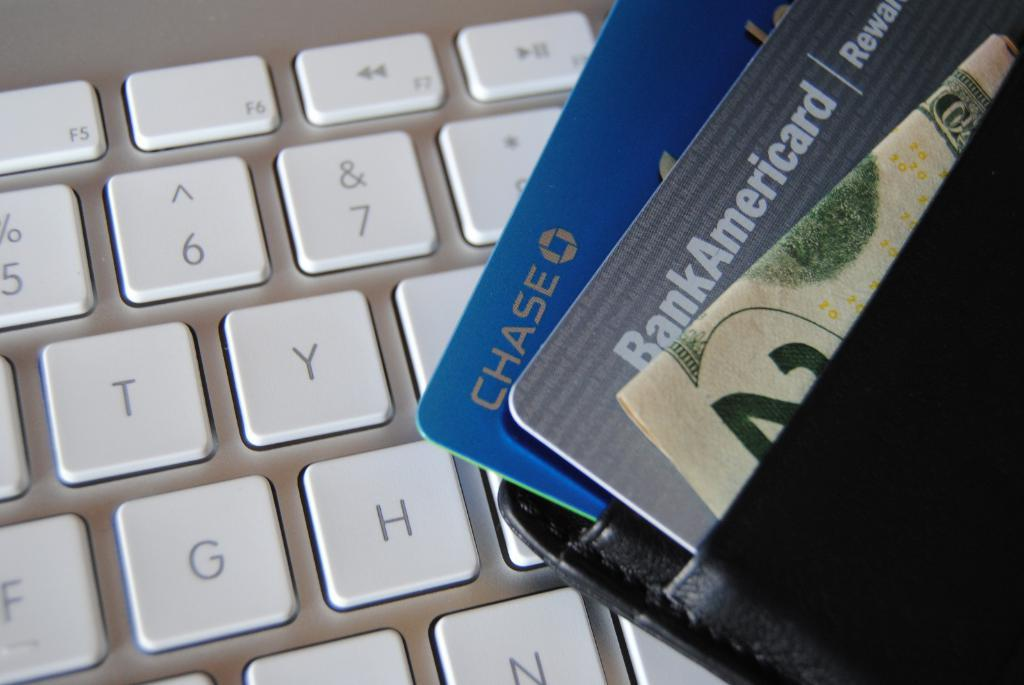<image>
Summarize the visual content of the image. A wallet with BankAmericard and Chase credit cards with a twenty dollar bill in the compartment laying on a keyboard to a computer. 